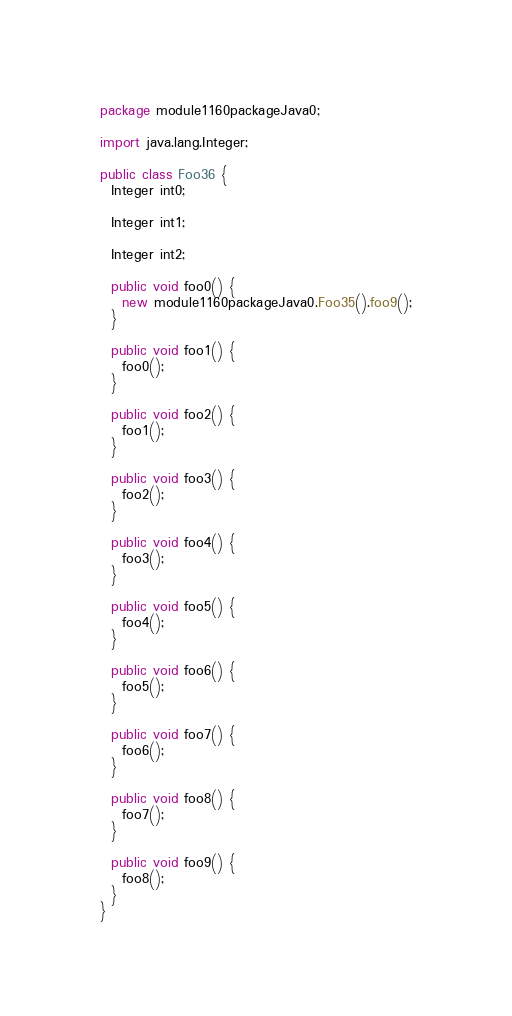<code> <loc_0><loc_0><loc_500><loc_500><_Java_>package module1160packageJava0;

import java.lang.Integer;

public class Foo36 {
  Integer int0;

  Integer int1;

  Integer int2;

  public void foo0() {
    new module1160packageJava0.Foo35().foo9();
  }

  public void foo1() {
    foo0();
  }

  public void foo2() {
    foo1();
  }

  public void foo3() {
    foo2();
  }

  public void foo4() {
    foo3();
  }

  public void foo5() {
    foo4();
  }

  public void foo6() {
    foo5();
  }

  public void foo7() {
    foo6();
  }

  public void foo8() {
    foo7();
  }

  public void foo9() {
    foo8();
  }
}
</code> 